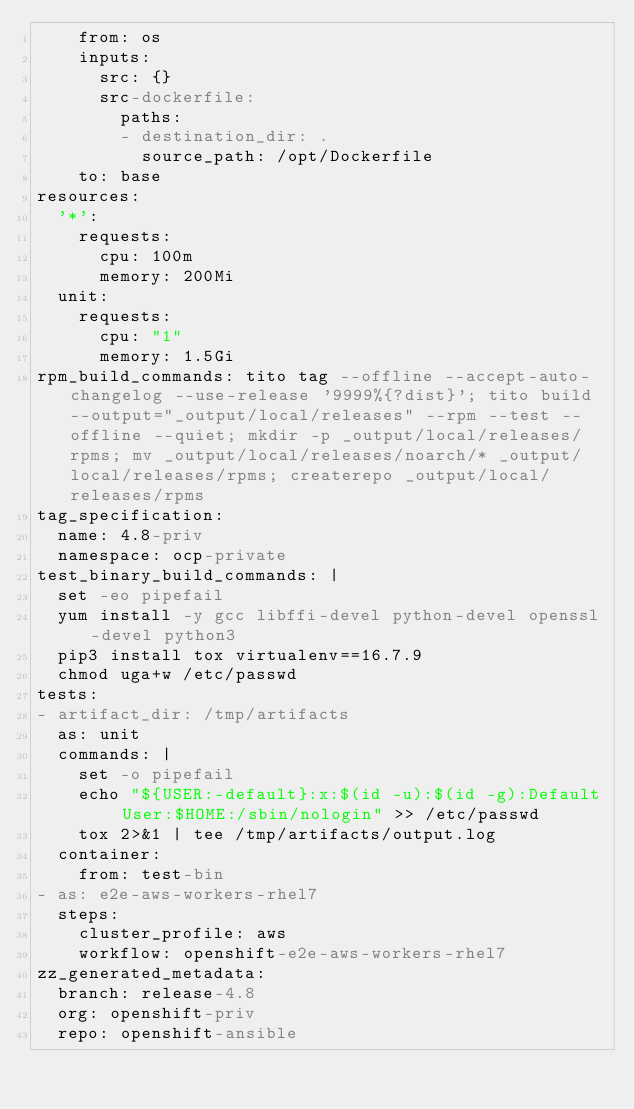Convert code to text. <code><loc_0><loc_0><loc_500><loc_500><_YAML_>    from: os
    inputs:
      src: {}
      src-dockerfile:
        paths:
        - destination_dir: .
          source_path: /opt/Dockerfile
    to: base
resources:
  '*':
    requests:
      cpu: 100m
      memory: 200Mi
  unit:
    requests:
      cpu: "1"
      memory: 1.5Gi
rpm_build_commands: tito tag --offline --accept-auto-changelog --use-release '9999%{?dist}'; tito build --output="_output/local/releases" --rpm --test --offline --quiet; mkdir -p _output/local/releases/rpms; mv _output/local/releases/noarch/* _output/local/releases/rpms; createrepo _output/local/releases/rpms
tag_specification:
  name: 4.8-priv
  namespace: ocp-private
test_binary_build_commands: |
  set -eo pipefail
  yum install -y gcc libffi-devel python-devel openssl-devel python3
  pip3 install tox virtualenv==16.7.9
  chmod uga+w /etc/passwd
tests:
- artifact_dir: /tmp/artifacts
  as: unit
  commands: |
    set -o pipefail
    echo "${USER:-default}:x:$(id -u):$(id -g):Default User:$HOME:/sbin/nologin" >> /etc/passwd
    tox 2>&1 | tee /tmp/artifacts/output.log
  container:
    from: test-bin
- as: e2e-aws-workers-rhel7
  steps:
    cluster_profile: aws
    workflow: openshift-e2e-aws-workers-rhel7
zz_generated_metadata:
  branch: release-4.8
  org: openshift-priv
  repo: openshift-ansible
</code> 